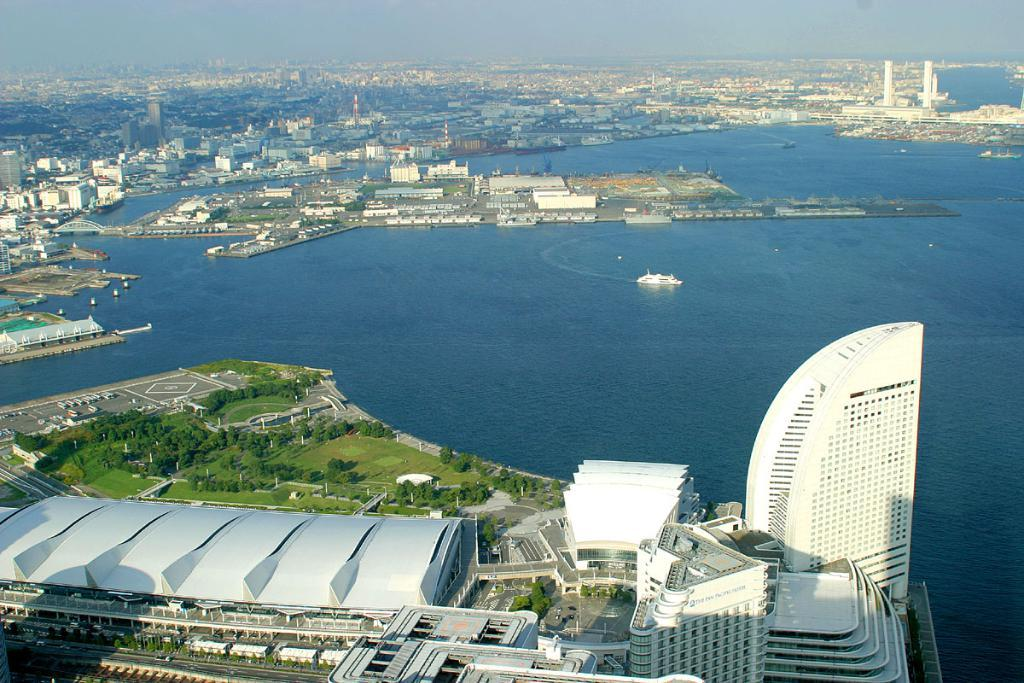What is the main feature of the image? The main feature of the image is water. What else can be seen in the image besides water? There is a ship, buildings, trees, the sky, a road, vehicles, and towers in the image. Can you describe the type of vehicles in the image? The vehicles in the image are not specified, but they are present. What is the relationship between the water and the other elements in the image? The water is likely a body of water, such as a river or ocean, and the other elements are situated near or around it. What type of fingerprint can be seen on the ship in the image? There is no fingerprint present on the ship in the image. What type of discovery was made near the towers in the image? There is no mention of a discovery in the image; it only shows a ship, water, buildings, trees, the sky, a road, vehicles, and towers. 